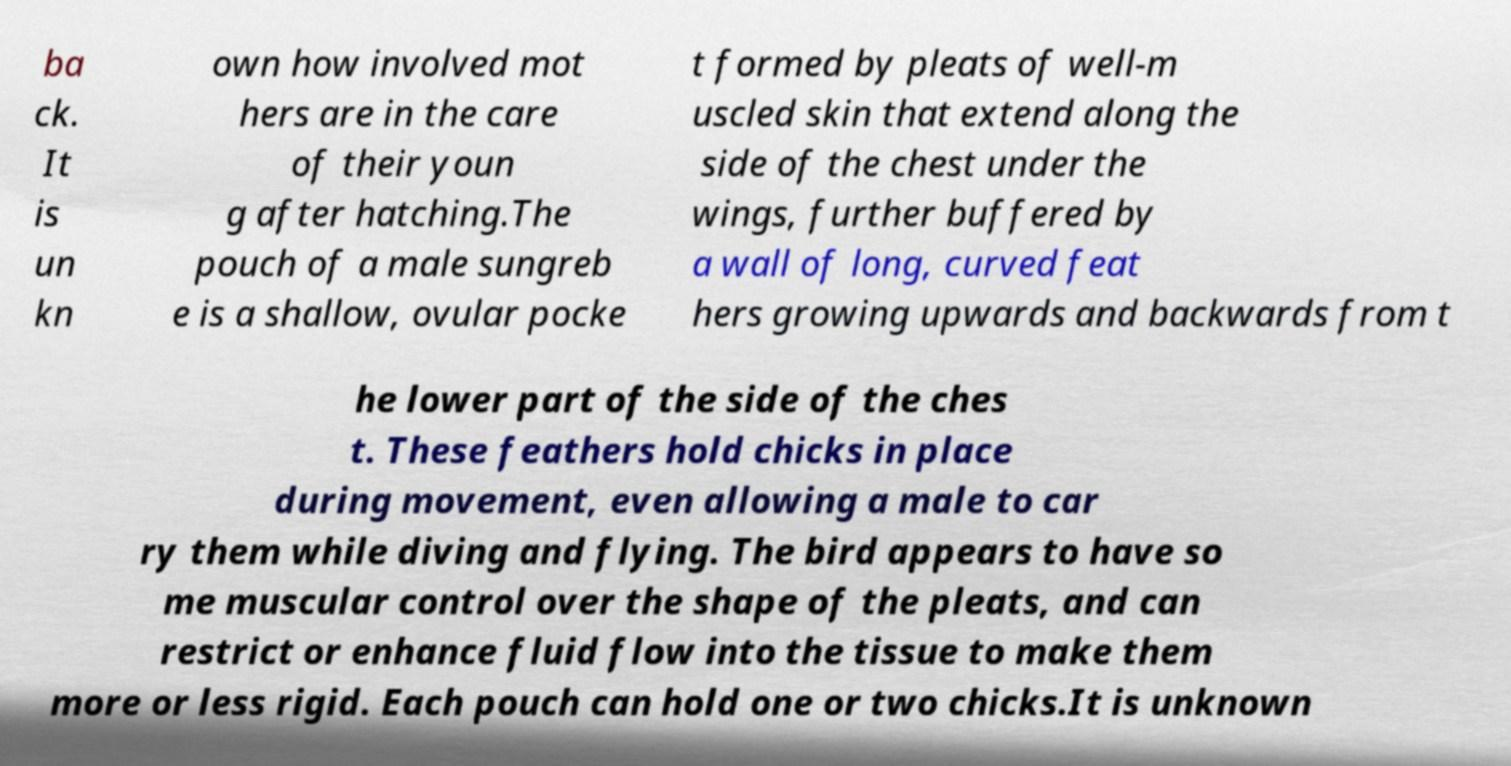Please read and relay the text visible in this image. What does it say? ba ck. It is un kn own how involved mot hers are in the care of their youn g after hatching.The pouch of a male sungreb e is a shallow, ovular pocke t formed by pleats of well-m uscled skin that extend along the side of the chest under the wings, further buffered by a wall of long, curved feat hers growing upwards and backwards from t he lower part of the side of the ches t. These feathers hold chicks in place during movement, even allowing a male to car ry them while diving and flying. The bird appears to have so me muscular control over the shape of the pleats, and can restrict or enhance fluid flow into the tissue to make them more or less rigid. Each pouch can hold one or two chicks.It is unknown 